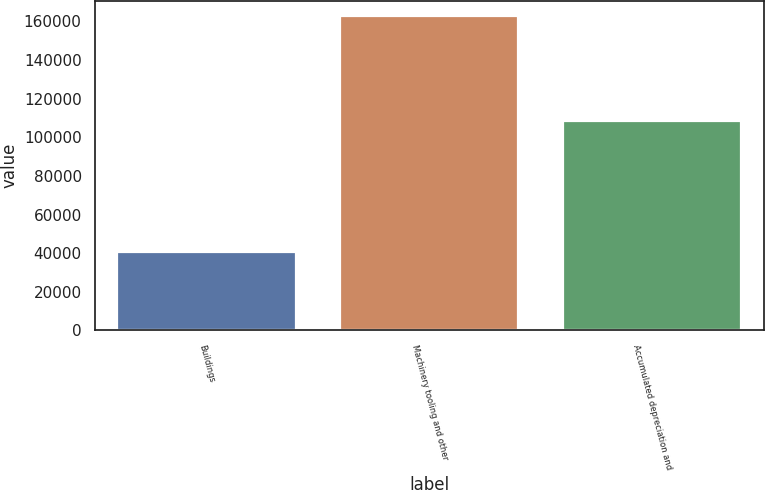Convert chart to OTSL. <chart><loc_0><loc_0><loc_500><loc_500><bar_chart><fcel>Buildings<fcel>Machinery tooling and other<fcel>Accumulated depreciation and<nl><fcel>40548<fcel>162501<fcel>108509<nl></chart> 